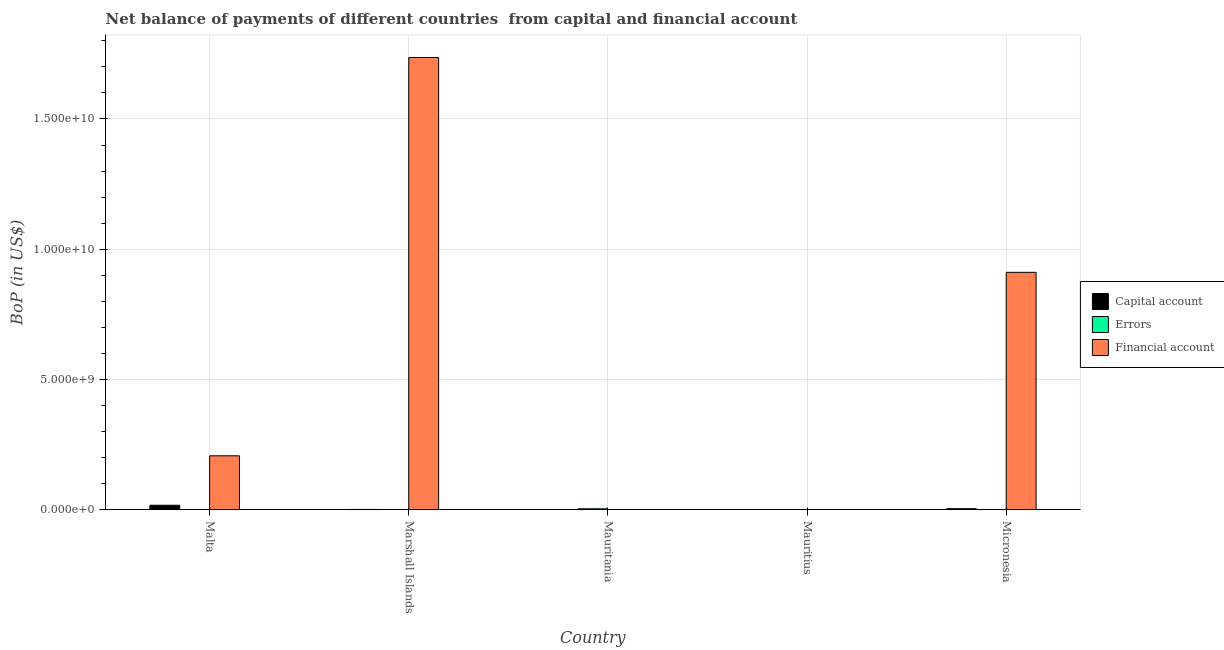How many different coloured bars are there?
Offer a very short reply. 3. How many bars are there on the 2nd tick from the right?
Offer a very short reply. 0. What is the label of the 2nd group of bars from the left?
Provide a succinct answer. Marshall Islands. In how many cases, is the number of bars for a given country not equal to the number of legend labels?
Provide a short and direct response. 4. What is the amount of net capital account in Mauritania?
Offer a very short reply. 4.90e+06. Across all countries, what is the maximum amount of net capital account?
Provide a short and direct response. 1.73e+08. In which country was the amount of errors maximum?
Offer a terse response. Mauritania. What is the total amount of errors in the graph?
Provide a succinct answer. 4.14e+07. What is the difference between the amount of financial account in Marshall Islands and that in Micronesia?
Provide a short and direct response. 8.25e+09. What is the average amount of net capital account per country?
Keep it short and to the point. 4.67e+07. What is the difference between the amount of net capital account and amount of financial account in Marshall Islands?
Offer a terse response. -1.73e+1. In how many countries, is the amount of financial account greater than 5000000000 US$?
Provide a succinct answer. 2. What is the ratio of the amount of financial account in Malta to that in Marshall Islands?
Provide a short and direct response. 0.12. Is the amount of errors in Malta less than that in Mauritania?
Provide a succinct answer. Yes. Is the difference between the amount of net capital account in Malta and Mauritania greater than the difference between the amount of errors in Malta and Mauritania?
Your answer should be very brief. Yes. What is the difference between the highest and the second highest amount of financial account?
Provide a short and direct response. 8.25e+09. What is the difference between the highest and the lowest amount of net capital account?
Offer a very short reply. 1.73e+08. Are all the bars in the graph horizontal?
Offer a terse response. No. Does the graph contain any zero values?
Make the answer very short. Yes. How many legend labels are there?
Provide a succinct answer. 3. What is the title of the graph?
Your answer should be compact. Net balance of payments of different countries  from capital and financial account. What is the label or title of the X-axis?
Provide a short and direct response. Country. What is the label or title of the Y-axis?
Your response must be concise. BoP (in US$). What is the BoP (in US$) of Capital account in Malta?
Offer a terse response. 1.73e+08. What is the BoP (in US$) of Errors in Malta?
Offer a very short reply. 4.16e+06. What is the BoP (in US$) in Financial account in Malta?
Offer a terse response. 2.07e+09. What is the BoP (in US$) of Capital account in Marshall Islands?
Your answer should be compact. 1.29e+07. What is the BoP (in US$) of Errors in Marshall Islands?
Keep it short and to the point. 0. What is the BoP (in US$) of Financial account in Marshall Islands?
Your answer should be compact. 1.74e+1. What is the BoP (in US$) in Capital account in Mauritania?
Give a very brief answer. 4.90e+06. What is the BoP (in US$) in Errors in Mauritania?
Offer a terse response. 3.72e+07. What is the BoP (in US$) in Financial account in Mauritania?
Your answer should be very brief. 0. What is the BoP (in US$) of Errors in Mauritius?
Provide a succinct answer. 0. What is the BoP (in US$) in Capital account in Micronesia?
Your response must be concise. 4.22e+07. What is the BoP (in US$) of Errors in Micronesia?
Offer a very short reply. 0. What is the BoP (in US$) of Financial account in Micronesia?
Give a very brief answer. 9.11e+09. Across all countries, what is the maximum BoP (in US$) of Capital account?
Give a very brief answer. 1.73e+08. Across all countries, what is the maximum BoP (in US$) of Errors?
Offer a very short reply. 3.72e+07. Across all countries, what is the maximum BoP (in US$) in Financial account?
Ensure brevity in your answer.  1.74e+1. Across all countries, what is the minimum BoP (in US$) of Errors?
Offer a very short reply. 0. Across all countries, what is the minimum BoP (in US$) in Financial account?
Keep it short and to the point. 0. What is the total BoP (in US$) of Capital account in the graph?
Offer a very short reply. 2.33e+08. What is the total BoP (in US$) of Errors in the graph?
Offer a very short reply. 4.14e+07. What is the total BoP (in US$) of Financial account in the graph?
Provide a short and direct response. 2.85e+1. What is the difference between the BoP (in US$) of Capital account in Malta and that in Marshall Islands?
Your response must be concise. 1.60e+08. What is the difference between the BoP (in US$) of Financial account in Malta and that in Marshall Islands?
Make the answer very short. -1.53e+1. What is the difference between the BoP (in US$) of Capital account in Malta and that in Mauritania?
Provide a succinct answer. 1.68e+08. What is the difference between the BoP (in US$) of Errors in Malta and that in Mauritania?
Make the answer very short. -3.30e+07. What is the difference between the BoP (in US$) of Capital account in Malta and that in Micronesia?
Ensure brevity in your answer.  1.31e+08. What is the difference between the BoP (in US$) of Financial account in Malta and that in Micronesia?
Provide a short and direct response. -7.04e+09. What is the difference between the BoP (in US$) in Capital account in Marshall Islands and that in Mauritania?
Offer a terse response. 8.01e+06. What is the difference between the BoP (in US$) in Capital account in Marshall Islands and that in Micronesia?
Your response must be concise. -2.93e+07. What is the difference between the BoP (in US$) in Financial account in Marshall Islands and that in Micronesia?
Offer a terse response. 8.25e+09. What is the difference between the BoP (in US$) in Capital account in Mauritania and that in Micronesia?
Offer a very short reply. -3.73e+07. What is the difference between the BoP (in US$) of Capital account in Malta and the BoP (in US$) of Financial account in Marshall Islands?
Give a very brief answer. -1.72e+1. What is the difference between the BoP (in US$) of Errors in Malta and the BoP (in US$) of Financial account in Marshall Islands?
Your answer should be very brief. -1.74e+1. What is the difference between the BoP (in US$) of Capital account in Malta and the BoP (in US$) of Errors in Mauritania?
Your answer should be very brief. 1.36e+08. What is the difference between the BoP (in US$) in Capital account in Malta and the BoP (in US$) in Financial account in Micronesia?
Your response must be concise. -8.94e+09. What is the difference between the BoP (in US$) in Errors in Malta and the BoP (in US$) in Financial account in Micronesia?
Keep it short and to the point. -9.11e+09. What is the difference between the BoP (in US$) in Capital account in Marshall Islands and the BoP (in US$) in Errors in Mauritania?
Give a very brief answer. -2.43e+07. What is the difference between the BoP (in US$) of Capital account in Marshall Islands and the BoP (in US$) of Financial account in Micronesia?
Provide a succinct answer. -9.10e+09. What is the difference between the BoP (in US$) of Capital account in Mauritania and the BoP (in US$) of Financial account in Micronesia?
Your response must be concise. -9.11e+09. What is the difference between the BoP (in US$) in Errors in Mauritania and the BoP (in US$) in Financial account in Micronesia?
Provide a short and direct response. -9.08e+09. What is the average BoP (in US$) of Capital account per country?
Your answer should be very brief. 4.67e+07. What is the average BoP (in US$) of Errors per country?
Give a very brief answer. 8.27e+06. What is the average BoP (in US$) of Financial account per country?
Your answer should be compact. 5.71e+09. What is the difference between the BoP (in US$) of Capital account and BoP (in US$) of Errors in Malta?
Provide a short and direct response. 1.69e+08. What is the difference between the BoP (in US$) of Capital account and BoP (in US$) of Financial account in Malta?
Give a very brief answer. -1.90e+09. What is the difference between the BoP (in US$) of Errors and BoP (in US$) of Financial account in Malta?
Keep it short and to the point. -2.07e+09. What is the difference between the BoP (in US$) of Capital account and BoP (in US$) of Financial account in Marshall Islands?
Provide a short and direct response. -1.73e+1. What is the difference between the BoP (in US$) in Capital account and BoP (in US$) in Errors in Mauritania?
Offer a very short reply. -3.23e+07. What is the difference between the BoP (in US$) of Capital account and BoP (in US$) of Financial account in Micronesia?
Your answer should be compact. -9.07e+09. What is the ratio of the BoP (in US$) of Capital account in Malta to that in Marshall Islands?
Keep it short and to the point. 13.42. What is the ratio of the BoP (in US$) in Financial account in Malta to that in Marshall Islands?
Your answer should be very brief. 0.12. What is the ratio of the BoP (in US$) in Capital account in Malta to that in Mauritania?
Your answer should be very brief. 35.37. What is the ratio of the BoP (in US$) in Errors in Malta to that in Mauritania?
Provide a succinct answer. 0.11. What is the ratio of the BoP (in US$) of Capital account in Malta to that in Micronesia?
Your answer should be compact. 4.11. What is the ratio of the BoP (in US$) in Financial account in Malta to that in Micronesia?
Make the answer very short. 0.23. What is the ratio of the BoP (in US$) in Capital account in Marshall Islands to that in Mauritania?
Your response must be concise. 2.64. What is the ratio of the BoP (in US$) of Capital account in Marshall Islands to that in Micronesia?
Ensure brevity in your answer.  0.31. What is the ratio of the BoP (in US$) in Financial account in Marshall Islands to that in Micronesia?
Your answer should be very brief. 1.9. What is the ratio of the BoP (in US$) in Capital account in Mauritania to that in Micronesia?
Make the answer very short. 0.12. What is the difference between the highest and the second highest BoP (in US$) of Capital account?
Your answer should be very brief. 1.31e+08. What is the difference between the highest and the second highest BoP (in US$) of Financial account?
Provide a succinct answer. 8.25e+09. What is the difference between the highest and the lowest BoP (in US$) in Capital account?
Provide a succinct answer. 1.73e+08. What is the difference between the highest and the lowest BoP (in US$) in Errors?
Provide a short and direct response. 3.72e+07. What is the difference between the highest and the lowest BoP (in US$) in Financial account?
Provide a short and direct response. 1.74e+1. 